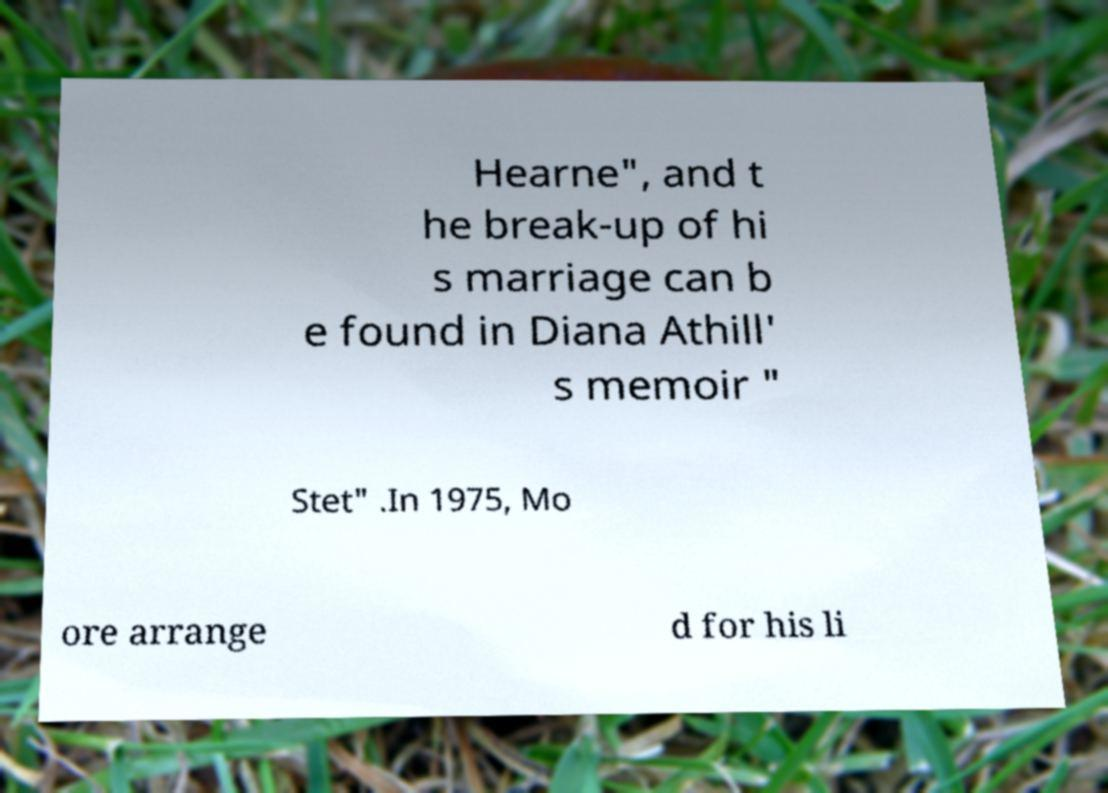I need the written content from this picture converted into text. Can you do that? Hearne", and t he break-up of hi s marriage can b e found in Diana Athill' s memoir " Stet" .In 1975, Mo ore arrange d for his li 